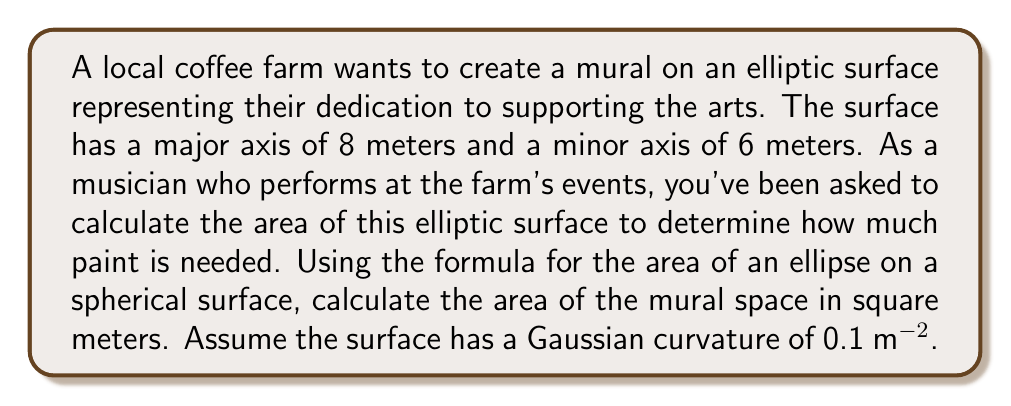Can you answer this question? To solve this problem, we'll use the formula for the area of an ellipse on a curved surface with constant Gaussian curvature. The steps are as follows:

1) The formula for the area of an ellipse on a surface with constant Gaussian curvature K is:

   $$A = \frac{4\pi ab}{4 + Kab}$$

   where $a$ and $b$ are the semi-major and semi-minor axes respectively.

2) We're given:
   - Major axis = 8 m, so $a = 4$ m
   - Minor axis = 6 m, so $b = 3$ m
   - Gaussian curvature $K = 0.1$ $m^{-2}$

3) Let's substitute these values into our formula:

   $$A = \frac{4\pi (4)(3)}{4 + 0.1(4)(3)}$$

4) Simplify:
   $$A = \frac{48\pi}{4 + 1.2} = \frac{48\pi}{5.2}$$

5) Calculate:
   $$A \approx 29.0888 m^2$$

6) Round to two decimal places:
   $$A \approx 29.09 m^2$$

This is the area of the elliptic surface for the mural.
Answer: $29.09 m^2$ 